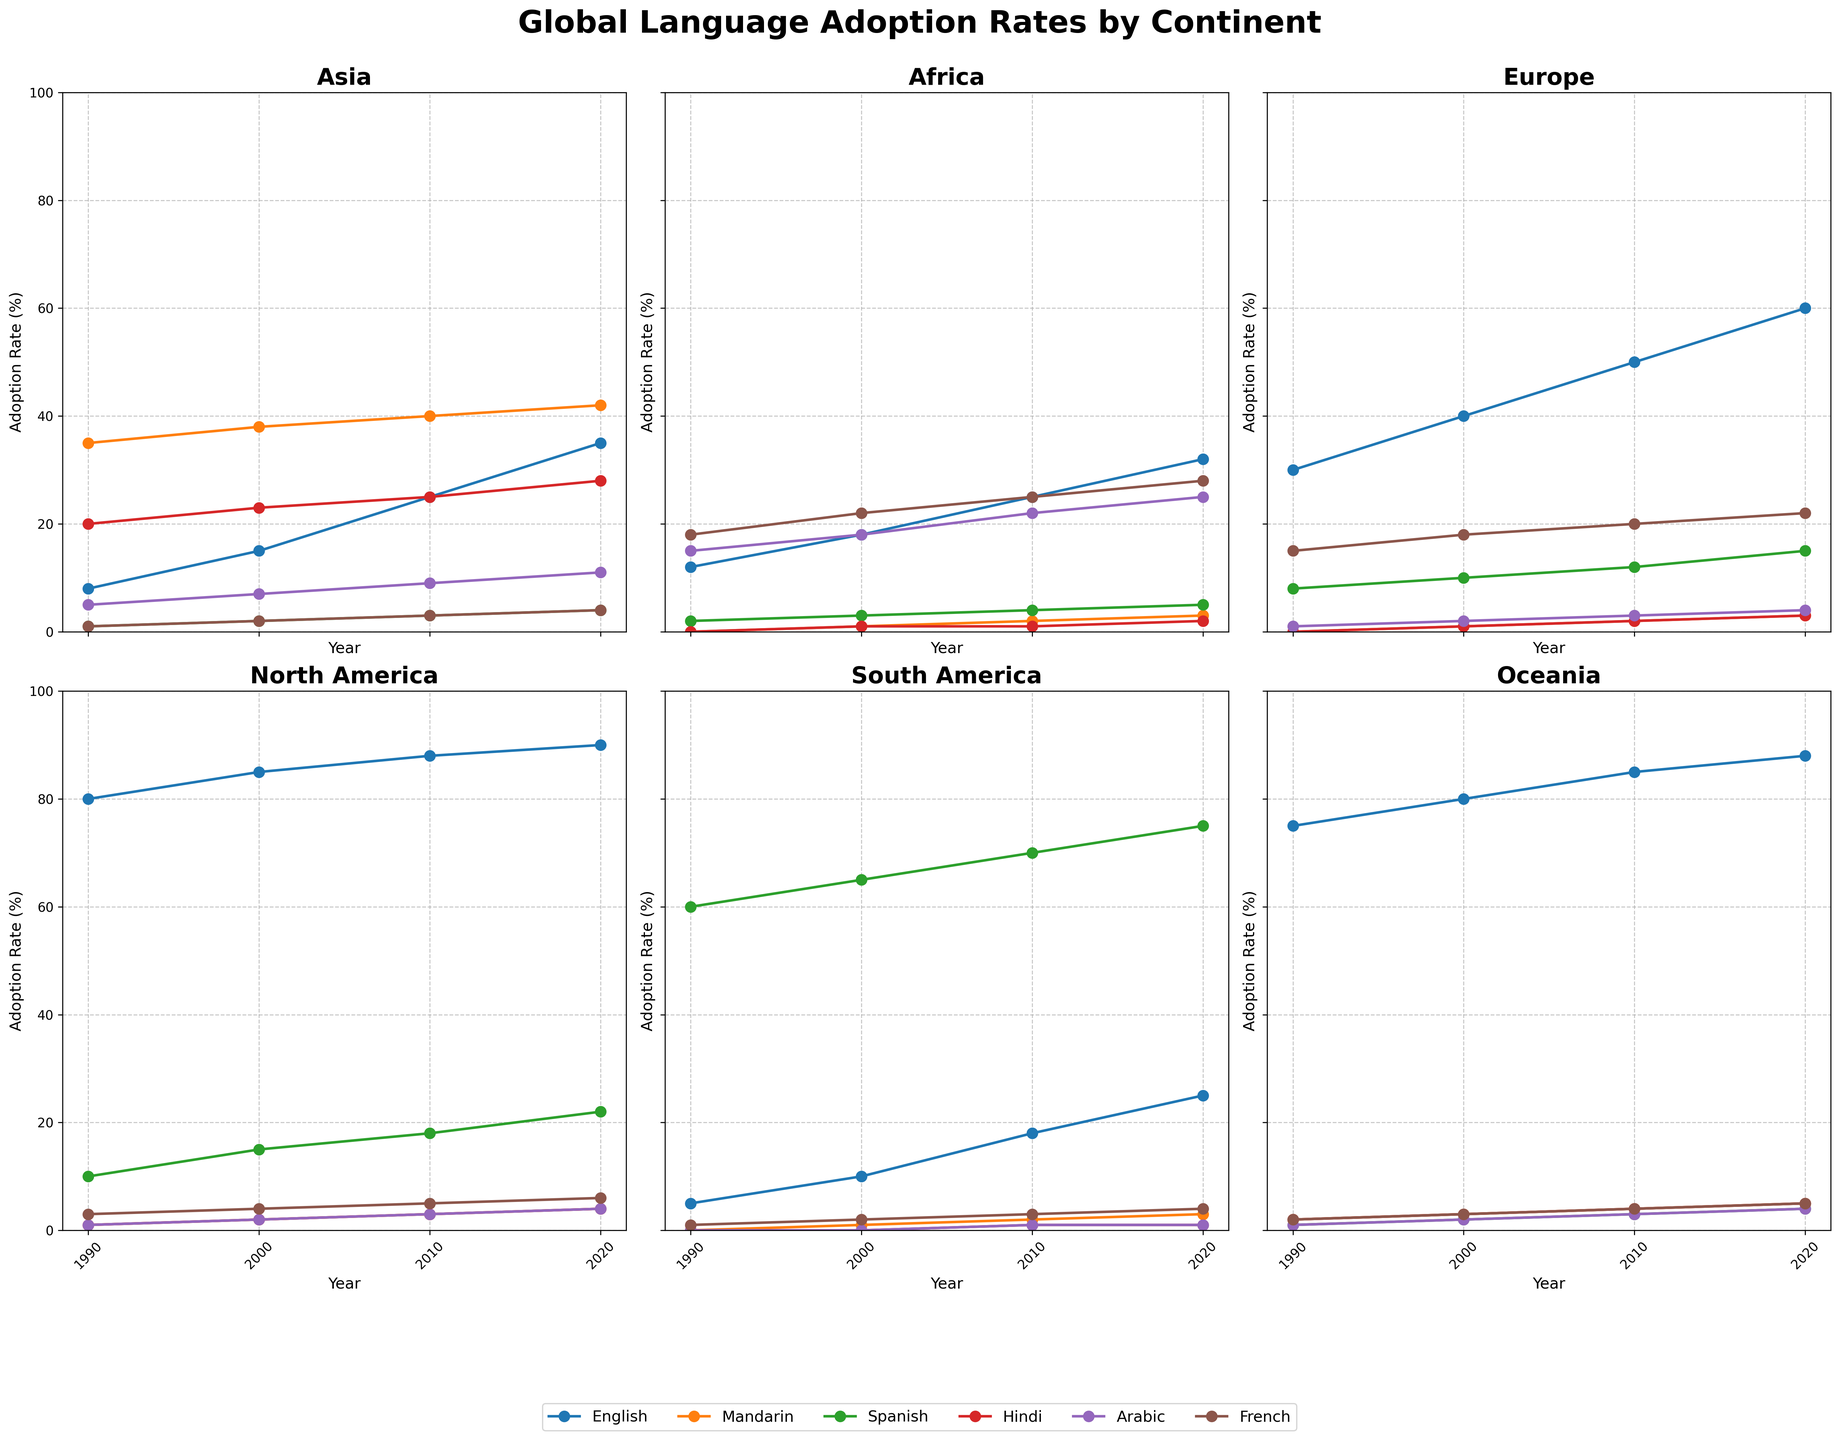What is the title of the figure? The title of the figure is displayed at the top center of the plot. By looking at the title area of the figure, the text "Global Language Adoption Rates by Continent" is visible.
Answer: Global Language Adoption Rates by Continent Which continent has the lowest English adoption rate in 2020? By examining the English adoption rates in 2020 for all continents, Africa has the lowest rate at 32%.
Answer: Africa How has the adoption rate of Mandarin in Asia changed from 1990 to 2020? By examining the trend for Mandarin in the Asia subplot from 1990 to 2020, we see: 35% (1990), 38% (2000), 40% (2010), and 42% (2020). The adoption rates steadily increased over the years.
Answer: Increased What is the average adoption rate of Arabic in Africa across all shown years? To calculate the average adoption rate of Arabic in Africa (15% in 1990, 18% in 2000, 22% in 2010, 25% in 2020): (15 + 18 + 22 + 25) / 4 = 20%
Answer: 20% Which language saw the greatest increase in adoption rate in South America from 1990 to 2020? By comparing the adoption rates of all six languages in South America from 1990 to 2020, Spanish saw the biggest increase from 60% to 75%, a 15% increase.
Answer: Spanish Did the adoption rate of any language decrease in Oceania from 1990 to 2020? By looking at the adoption rates of all six languages in Oceania, the rates increased or remained the same, so no language saw a decrease.
Answer: No What is the trend in the adoption rate of Hindi in North America from 1990 to 2020? By examining the North America subplot, Hindi rates are: 1% (1990), 2% (2000), 3% (2010), and 4% (2020), showing a steady increase over time.
Answer: Increasing How much did the adoption rate of French in Europe change between 1990 and 2000? By comparing the French adoption rates in Europe in 1990 (15%) and 2000 (18%), the increase is 18% - 15% = 3%.
Answer: 3% In 2010, which continent had the highest adoption rate of Spanish? By examining the Spanish rates in all continents for 2010, South America had the highest rate at 70%.
Answer: South America 